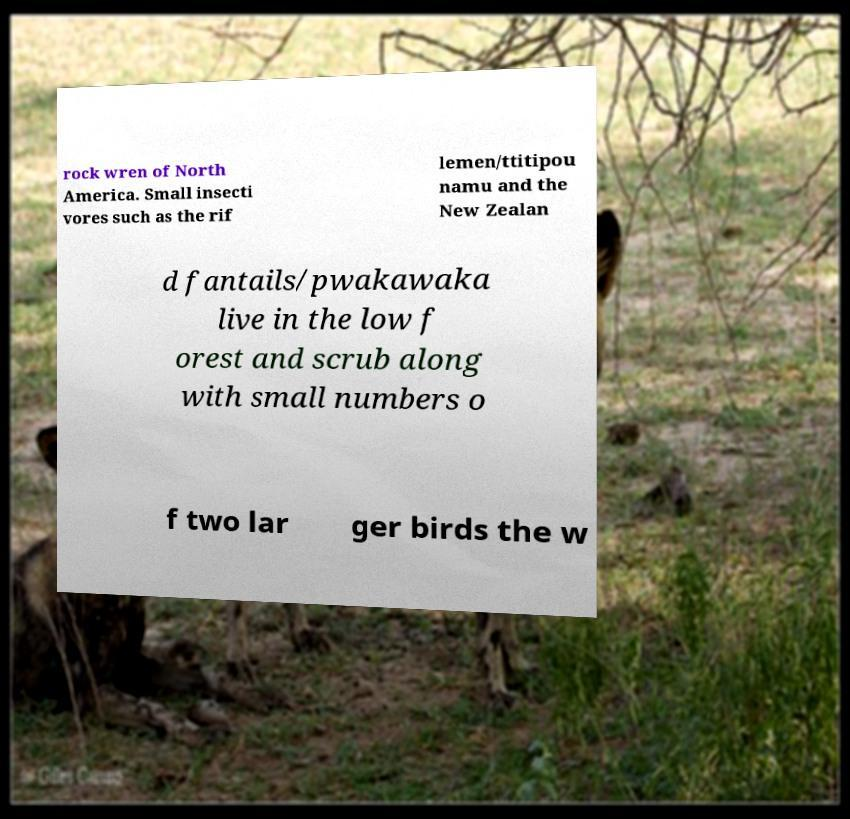Can you read and provide the text displayed in the image?This photo seems to have some interesting text. Can you extract and type it out for me? rock wren of North America. Small insecti vores such as the rif lemen/ttitipou namu and the New Zealan d fantails/pwakawaka live in the low f orest and scrub along with small numbers o f two lar ger birds the w 